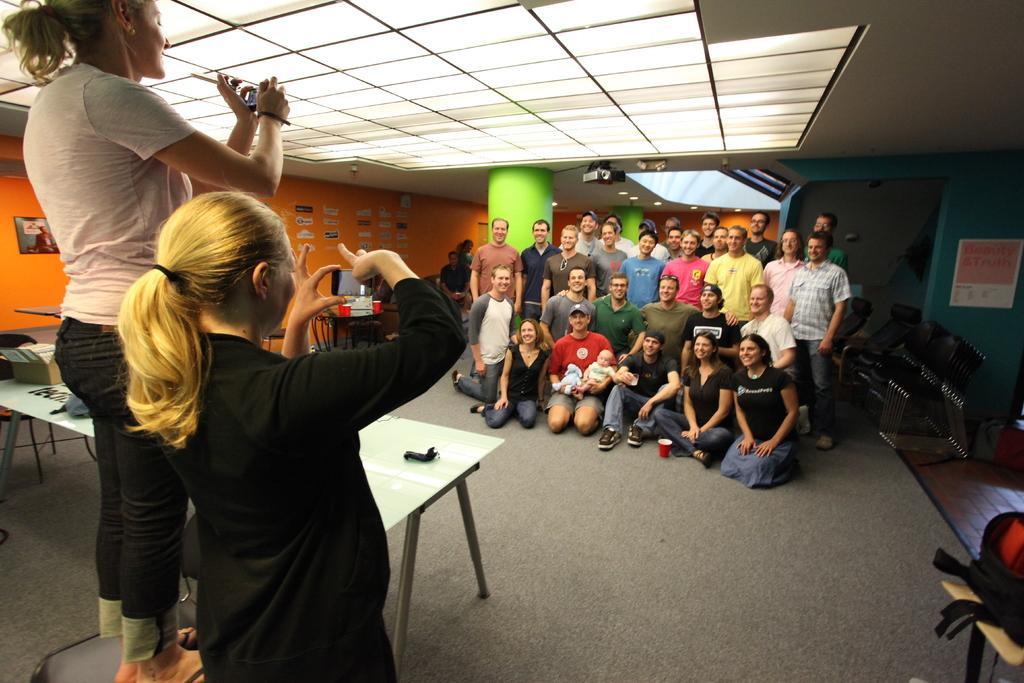Could you give a brief overview of what you see in this image? In this image there are two persons standing and holding some devices, and in the background there are group of people sitting on their knees and standing, table, chairs , lights, papers stick to the wall. 